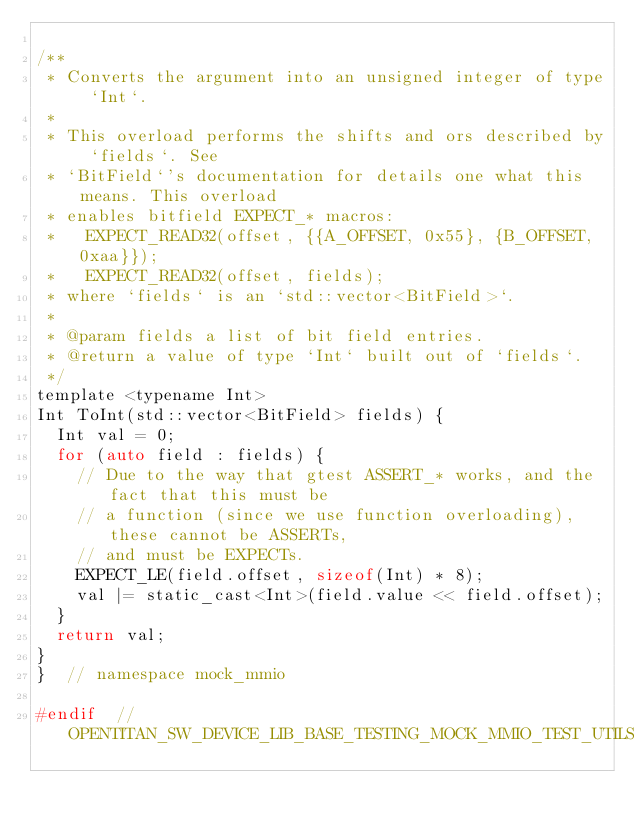<code> <loc_0><loc_0><loc_500><loc_500><_C_>
/**
 * Converts the argument into an unsigned integer of type `Int`.
 *
 * This overload performs the shifts and ors described by `fields`. See
 * `BitField`'s documentation for details one what this means. This overload
 * enables bitfield EXPECT_* macros:
 *   EXPECT_READ32(offset, {{A_OFFSET, 0x55}, {B_OFFSET, 0xaa}});
 *   EXPECT_READ32(offset, fields);
 * where `fields` is an `std::vector<BitField>`.
 *
 * @param fields a list of bit field entries.
 * @return a value of type `Int` built out of `fields`.
 */
template <typename Int>
Int ToInt(std::vector<BitField> fields) {
  Int val = 0;
  for (auto field : fields) {
    // Due to the way that gtest ASSERT_* works, and the fact that this must be
    // a function (since we use function overloading), these cannot be ASSERTs,
    // and must be EXPECTs.
    EXPECT_LE(field.offset, sizeof(Int) * 8);
    val |= static_cast<Int>(field.value << field.offset);
  }
  return val;
}
}  // namespace mock_mmio

#endif  // OPENTITAN_SW_DEVICE_LIB_BASE_TESTING_MOCK_MMIO_TEST_UTILS_H_
</code> 